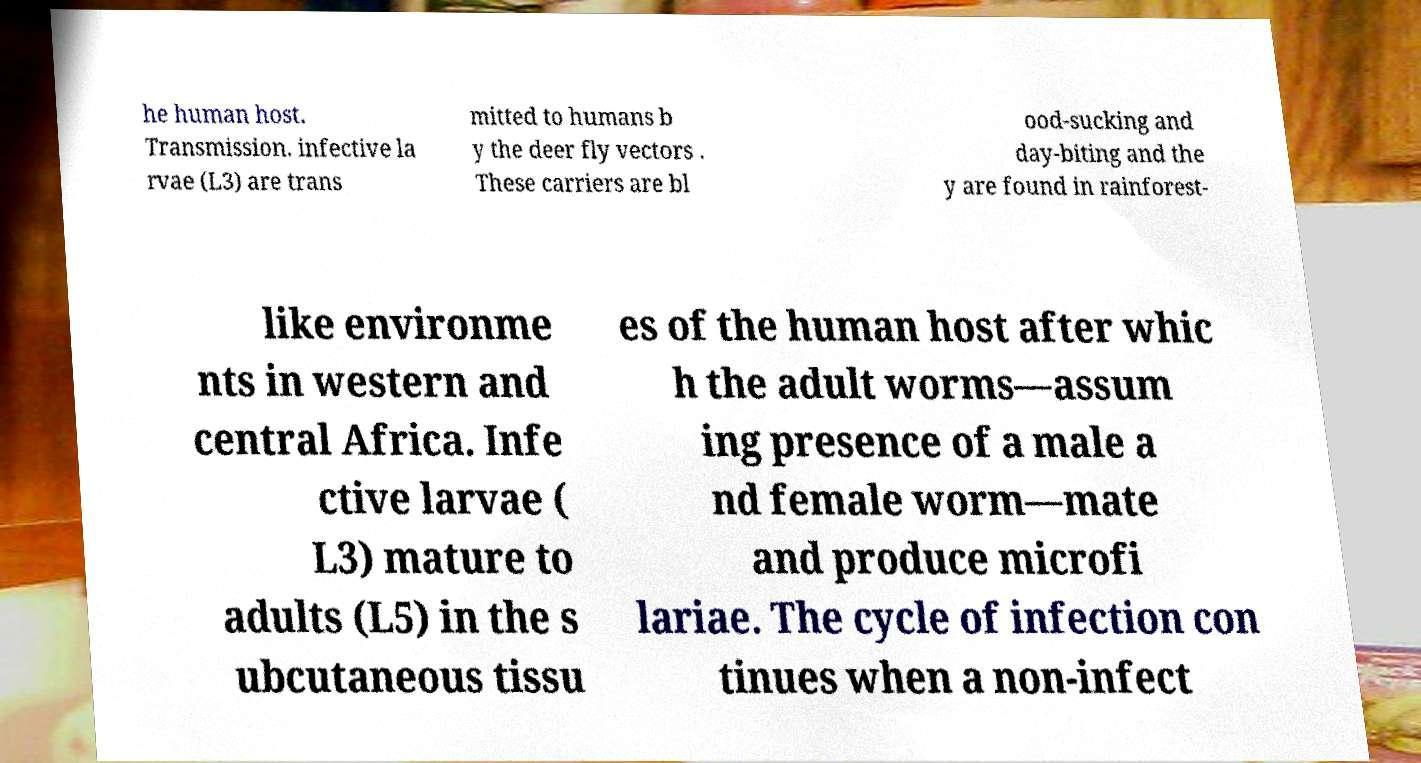For documentation purposes, I need the text within this image transcribed. Could you provide that? he human host. Transmission. infective la rvae (L3) are trans mitted to humans b y the deer fly vectors . These carriers are bl ood-sucking and day-biting and the y are found in rainforest- like environme nts in western and central Africa. Infe ctive larvae ( L3) mature to adults (L5) in the s ubcutaneous tissu es of the human host after whic h the adult worms—assum ing presence of a male a nd female worm—mate and produce microfi lariae. The cycle of infection con tinues when a non-infect 